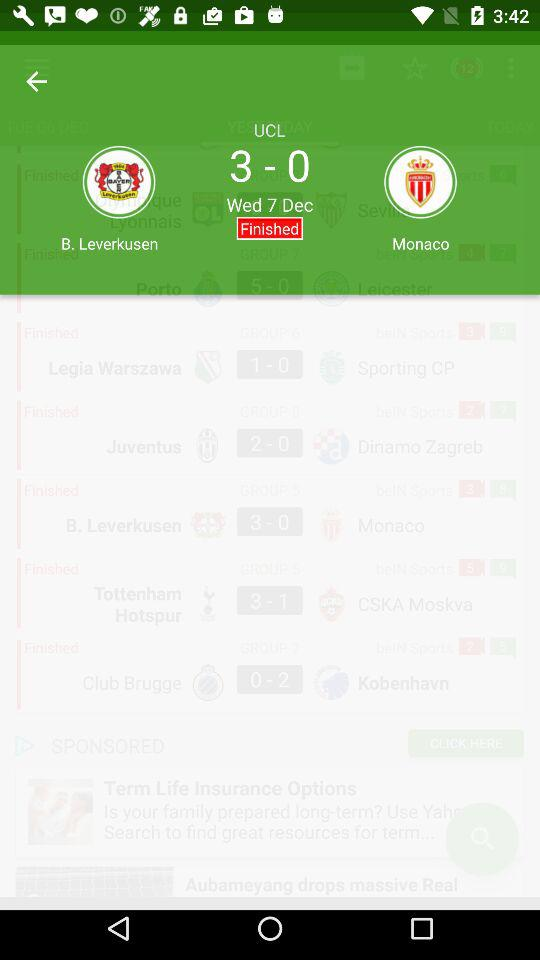What is the name of the two teams? The names of the two teams are B. Leverkusen and Monaco. 